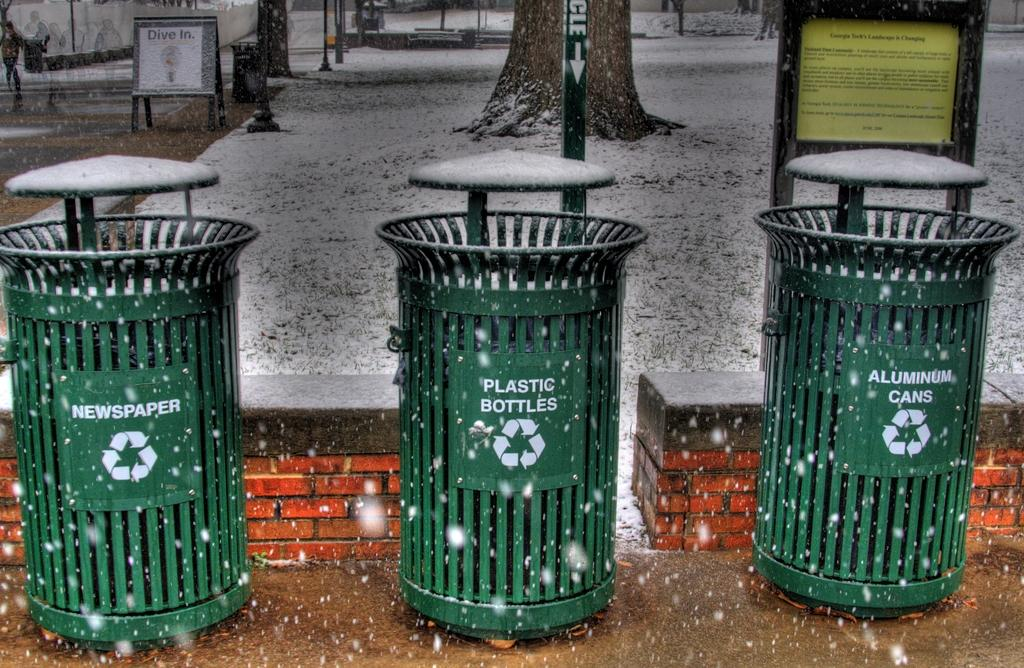<image>
Present a compact description of the photo's key features. Three different garbage cans, one labelled "Newspaper" are outside in the snow. 